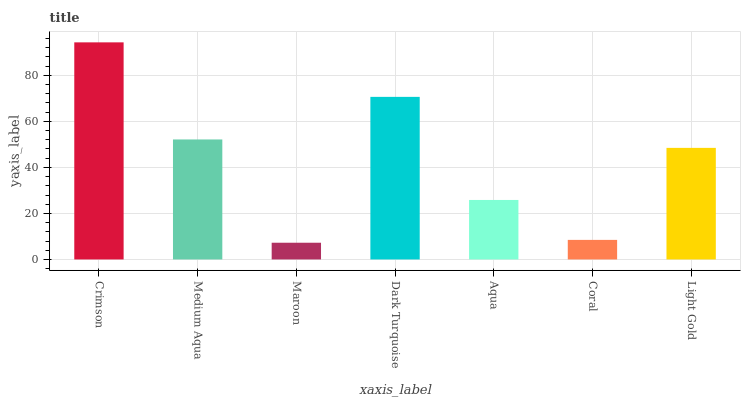Is Maroon the minimum?
Answer yes or no. Yes. Is Crimson the maximum?
Answer yes or no. Yes. Is Medium Aqua the minimum?
Answer yes or no. No. Is Medium Aqua the maximum?
Answer yes or no. No. Is Crimson greater than Medium Aqua?
Answer yes or no. Yes. Is Medium Aqua less than Crimson?
Answer yes or no. Yes. Is Medium Aqua greater than Crimson?
Answer yes or no. No. Is Crimson less than Medium Aqua?
Answer yes or no. No. Is Light Gold the high median?
Answer yes or no. Yes. Is Light Gold the low median?
Answer yes or no. Yes. Is Crimson the high median?
Answer yes or no. No. Is Medium Aqua the low median?
Answer yes or no. No. 